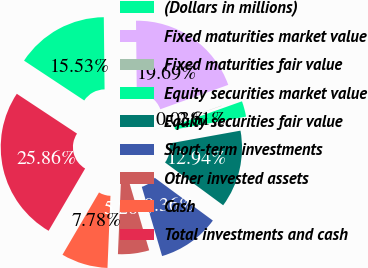Convert chart. <chart><loc_0><loc_0><loc_500><loc_500><pie_chart><fcel>(Dollars in millions)<fcel>Fixed maturities market value<fcel>Fixed maturities fair value<fcel>Equity securities market value<fcel>Equity securities fair value<fcel>Short-term investments<fcel>Other invested assets<fcel>Cash<fcel>Total investments and cash<nl><fcel>15.53%<fcel>19.69%<fcel>0.03%<fcel>2.61%<fcel>12.94%<fcel>10.36%<fcel>5.2%<fcel>7.78%<fcel>25.86%<nl></chart> 